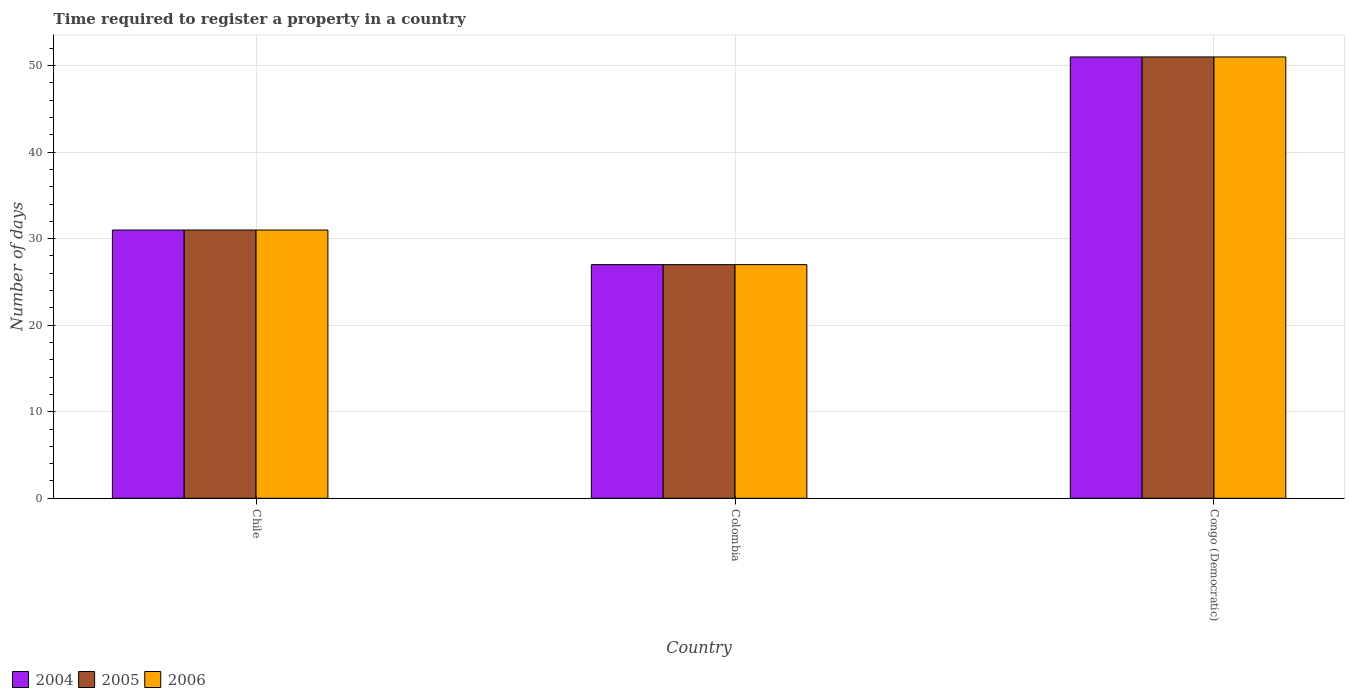How many groups of bars are there?
Your answer should be very brief. 3. Are the number of bars per tick equal to the number of legend labels?
Ensure brevity in your answer.  Yes. What is the label of the 3rd group of bars from the left?
Your answer should be compact. Congo (Democratic). In how many cases, is the number of bars for a given country not equal to the number of legend labels?
Provide a short and direct response. 0. What is the number of days required to register a property in 2006 in Chile?
Give a very brief answer. 31. Across all countries, what is the maximum number of days required to register a property in 2005?
Your answer should be compact. 51. In which country was the number of days required to register a property in 2006 maximum?
Your answer should be compact. Congo (Democratic). What is the total number of days required to register a property in 2005 in the graph?
Provide a succinct answer. 109. What is the difference between the number of days required to register a property in 2005 in Chile and the number of days required to register a property in 2006 in Congo (Democratic)?
Give a very brief answer. -20. What is the average number of days required to register a property in 2004 per country?
Keep it short and to the point. 36.33. What is the difference between the number of days required to register a property of/in 2004 and number of days required to register a property of/in 2005 in Congo (Democratic)?
Offer a terse response. 0. In how many countries, is the number of days required to register a property in 2006 greater than 6 days?
Provide a short and direct response. 3. What is the ratio of the number of days required to register a property in 2005 in Chile to that in Colombia?
Provide a short and direct response. 1.15. Is the number of days required to register a property in 2006 in Chile less than that in Congo (Democratic)?
Your answer should be very brief. Yes. Is the difference between the number of days required to register a property in 2004 in Chile and Colombia greater than the difference between the number of days required to register a property in 2005 in Chile and Colombia?
Give a very brief answer. No. What is the difference between the highest and the lowest number of days required to register a property in 2004?
Offer a terse response. 24. Is the sum of the number of days required to register a property in 2004 in Chile and Colombia greater than the maximum number of days required to register a property in 2006 across all countries?
Offer a terse response. Yes. What does the 3rd bar from the left in Chile represents?
Ensure brevity in your answer.  2006. What does the 3rd bar from the right in Congo (Democratic) represents?
Ensure brevity in your answer.  2004. Is it the case that in every country, the sum of the number of days required to register a property in 2004 and number of days required to register a property in 2005 is greater than the number of days required to register a property in 2006?
Ensure brevity in your answer.  Yes. How many bars are there?
Keep it short and to the point. 9. Are all the bars in the graph horizontal?
Your answer should be compact. No. Does the graph contain any zero values?
Provide a short and direct response. No. Where does the legend appear in the graph?
Provide a succinct answer. Bottom left. How are the legend labels stacked?
Offer a very short reply. Horizontal. What is the title of the graph?
Make the answer very short. Time required to register a property in a country. What is the label or title of the X-axis?
Ensure brevity in your answer.  Country. What is the label or title of the Y-axis?
Keep it short and to the point. Number of days. What is the Number of days of 2005 in Chile?
Give a very brief answer. 31. What is the Number of days in 2004 in Colombia?
Your answer should be compact. 27. What is the Number of days of 2005 in Colombia?
Your answer should be compact. 27. What is the Number of days of 2005 in Congo (Democratic)?
Your answer should be very brief. 51. What is the Number of days in 2006 in Congo (Democratic)?
Your answer should be very brief. 51. Across all countries, what is the maximum Number of days in 2005?
Your answer should be compact. 51. Across all countries, what is the maximum Number of days of 2006?
Your response must be concise. 51. Across all countries, what is the minimum Number of days in 2005?
Your response must be concise. 27. Across all countries, what is the minimum Number of days in 2006?
Your response must be concise. 27. What is the total Number of days of 2004 in the graph?
Keep it short and to the point. 109. What is the total Number of days of 2005 in the graph?
Provide a short and direct response. 109. What is the total Number of days of 2006 in the graph?
Ensure brevity in your answer.  109. What is the difference between the Number of days in 2004 in Chile and that in Colombia?
Your response must be concise. 4. What is the difference between the Number of days of 2005 in Chile and that in Colombia?
Make the answer very short. 4. What is the difference between the Number of days of 2006 in Chile and that in Colombia?
Make the answer very short. 4. What is the difference between the Number of days in 2006 in Chile and that in Congo (Democratic)?
Keep it short and to the point. -20. What is the difference between the Number of days of 2004 in Colombia and that in Congo (Democratic)?
Ensure brevity in your answer.  -24. What is the difference between the Number of days in 2005 in Colombia and that in Congo (Democratic)?
Give a very brief answer. -24. What is the difference between the Number of days in 2006 in Colombia and that in Congo (Democratic)?
Ensure brevity in your answer.  -24. What is the difference between the Number of days in 2004 in Chile and the Number of days in 2005 in Colombia?
Provide a succinct answer. 4. What is the difference between the Number of days of 2004 in Chile and the Number of days of 2006 in Colombia?
Give a very brief answer. 4. What is the difference between the Number of days of 2005 in Chile and the Number of days of 2006 in Colombia?
Keep it short and to the point. 4. What is the difference between the Number of days in 2004 in Chile and the Number of days in 2005 in Congo (Democratic)?
Keep it short and to the point. -20. What is the difference between the Number of days of 2004 in Chile and the Number of days of 2006 in Congo (Democratic)?
Keep it short and to the point. -20. What is the difference between the Number of days of 2004 in Colombia and the Number of days of 2006 in Congo (Democratic)?
Keep it short and to the point. -24. What is the average Number of days of 2004 per country?
Your response must be concise. 36.33. What is the average Number of days of 2005 per country?
Provide a succinct answer. 36.33. What is the average Number of days in 2006 per country?
Make the answer very short. 36.33. What is the difference between the Number of days of 2004 and Number of days of 2005 in Chile?
Provide a short and direct response. 0. What is the difference between the Number of days in 2004 and Number of days in 2006 in Chile?
Offer a very short reply. 0. What is the difference between the Number of days of 2005 and Number of days of 2006 in Chile?
Give a very brief answer. 0. What is the difference between the Number of days of 2004 and Number of days of 2006 in Colombia?
Provide a succinct answer. 0. What is the difference between the Number of days in 2004 and Number of days in 2005 in Congo (Democratic)?
Your answer should be very brief. 0. What is the difference between the Number of days in 2004 and Number of days in 2006 in Congo (Democratic)?
Offer a terse response. 0. What is the ratio of the Number of days of 2004 in Chile to that in Colombia?
Your answer should be compact. 1.15. What is the ratio of the Number of days of 2005 in Chile to that in Colombia?
Your answer should be compact. 1.15. What is the ratio of the Number of days in 2006 in Chile to that in Colombia?
Your answer should be very brief. 1.15. What is the ratio of the Number of days of 2004 in Chile to that in Congo (Democratic)?
Offer a very short reply. 0.61. What is the ratio of the Number of days in 2005 in Chile to that in Congo (Democratic)?
Provide a succinct answer. 0.61. What is the ratio of the Number of days in 2006 in Chile to that in Congo (Democratic)?
Give a very brief answer. 0.61. What is the ratio of the Number of days of 2004 in Colombia to that in Congo (Democratic)?
Keep it short and to the point. 0.53. What is the ratio of the Number of days of 2005 in Colombia to that in Congo (Democratic)?
Provide a short and direct response. 0.53. What is the ratio of the Number of days in 2006 in Colombia to that in Congo (Democratic)?
Provide a short and direct response. 0.53. What is the difference between the highest and the second highest Number of days in 2004?
Make the answer very short. 20. 